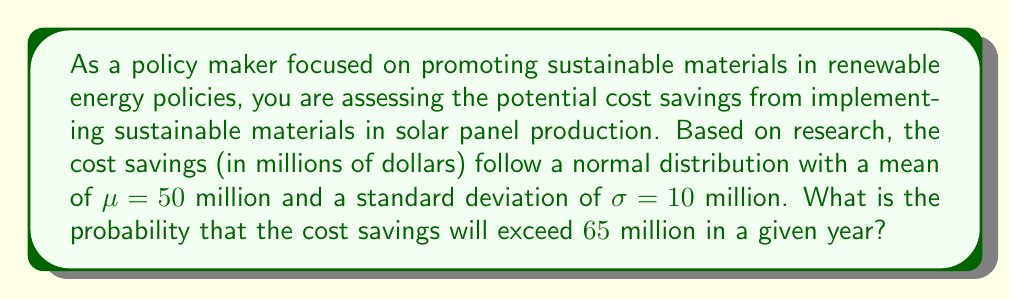Can you answer this question? To solve this problem, we need to use the properties of the normal distribution and the concept of z-scores.

1. First, we identify the given information:
   - The cost savings follow a normal distribution
   - Mean ($\mu$) = $50$ million
   - Standard deviation ($\sigma$) = $10$ million
   - We want to find P(X > 65), where X is the cost savings

2. Calculate the z-score for the given value:
   $$z = \frac{x - \mu}{\sigma} = \frac{65 - 50}{10} = 1.5$$

3. The problem is now equivalent to finding P(Z > 1.5), where Z is the standard normal variable.

4. Use the standard normal distribution table or a calculator to find the area to the right of z = 1.5.
   
   P(Z > 1.5) = 1 - P(Z < 1.5)
   
   From the standard normal table, P(Z < 1.5) ≈ 0.9332

   Therefore, P(Z > 1.5) = 1 - 0.9332 = 0.0668

5. Convert the probability to a percentage:
   0.0668 × 100% = 6.68%
Answer: The probability that the cost savings will exceed $65 million in a given year is approximately 6.68%. 